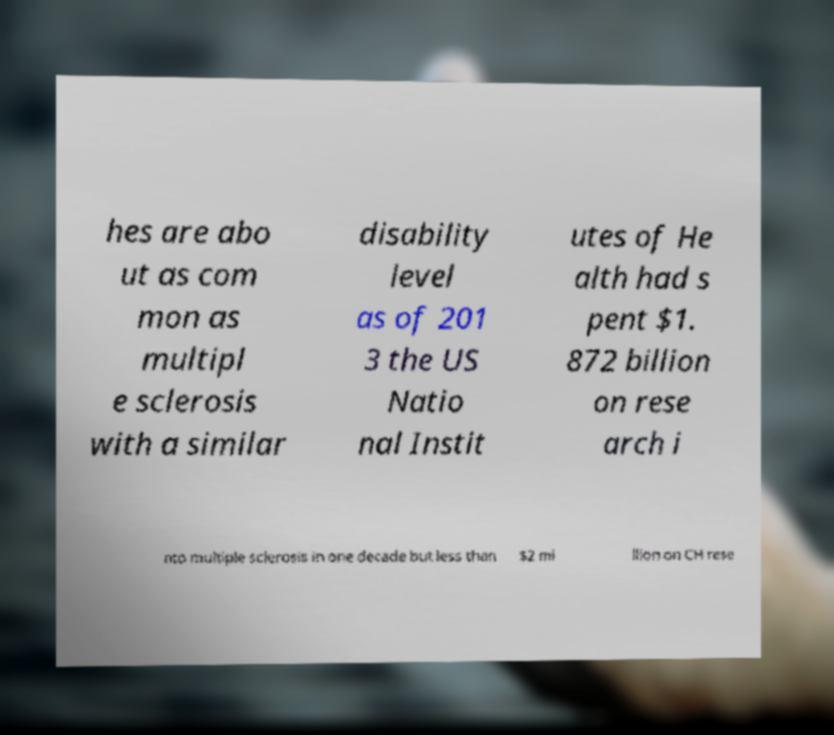For documentation purposes, I need the text within this image transcribed. Could you provide that? hes are abo ut as com mon as multipl e sclerosis with a similar disability level as of 201 3 the US Natio nal Instit utes of He alth had s pent $1. 872 billion on rese arch i nto multiple sclerosis in one decade but less than $2 mi llion on CH rese 